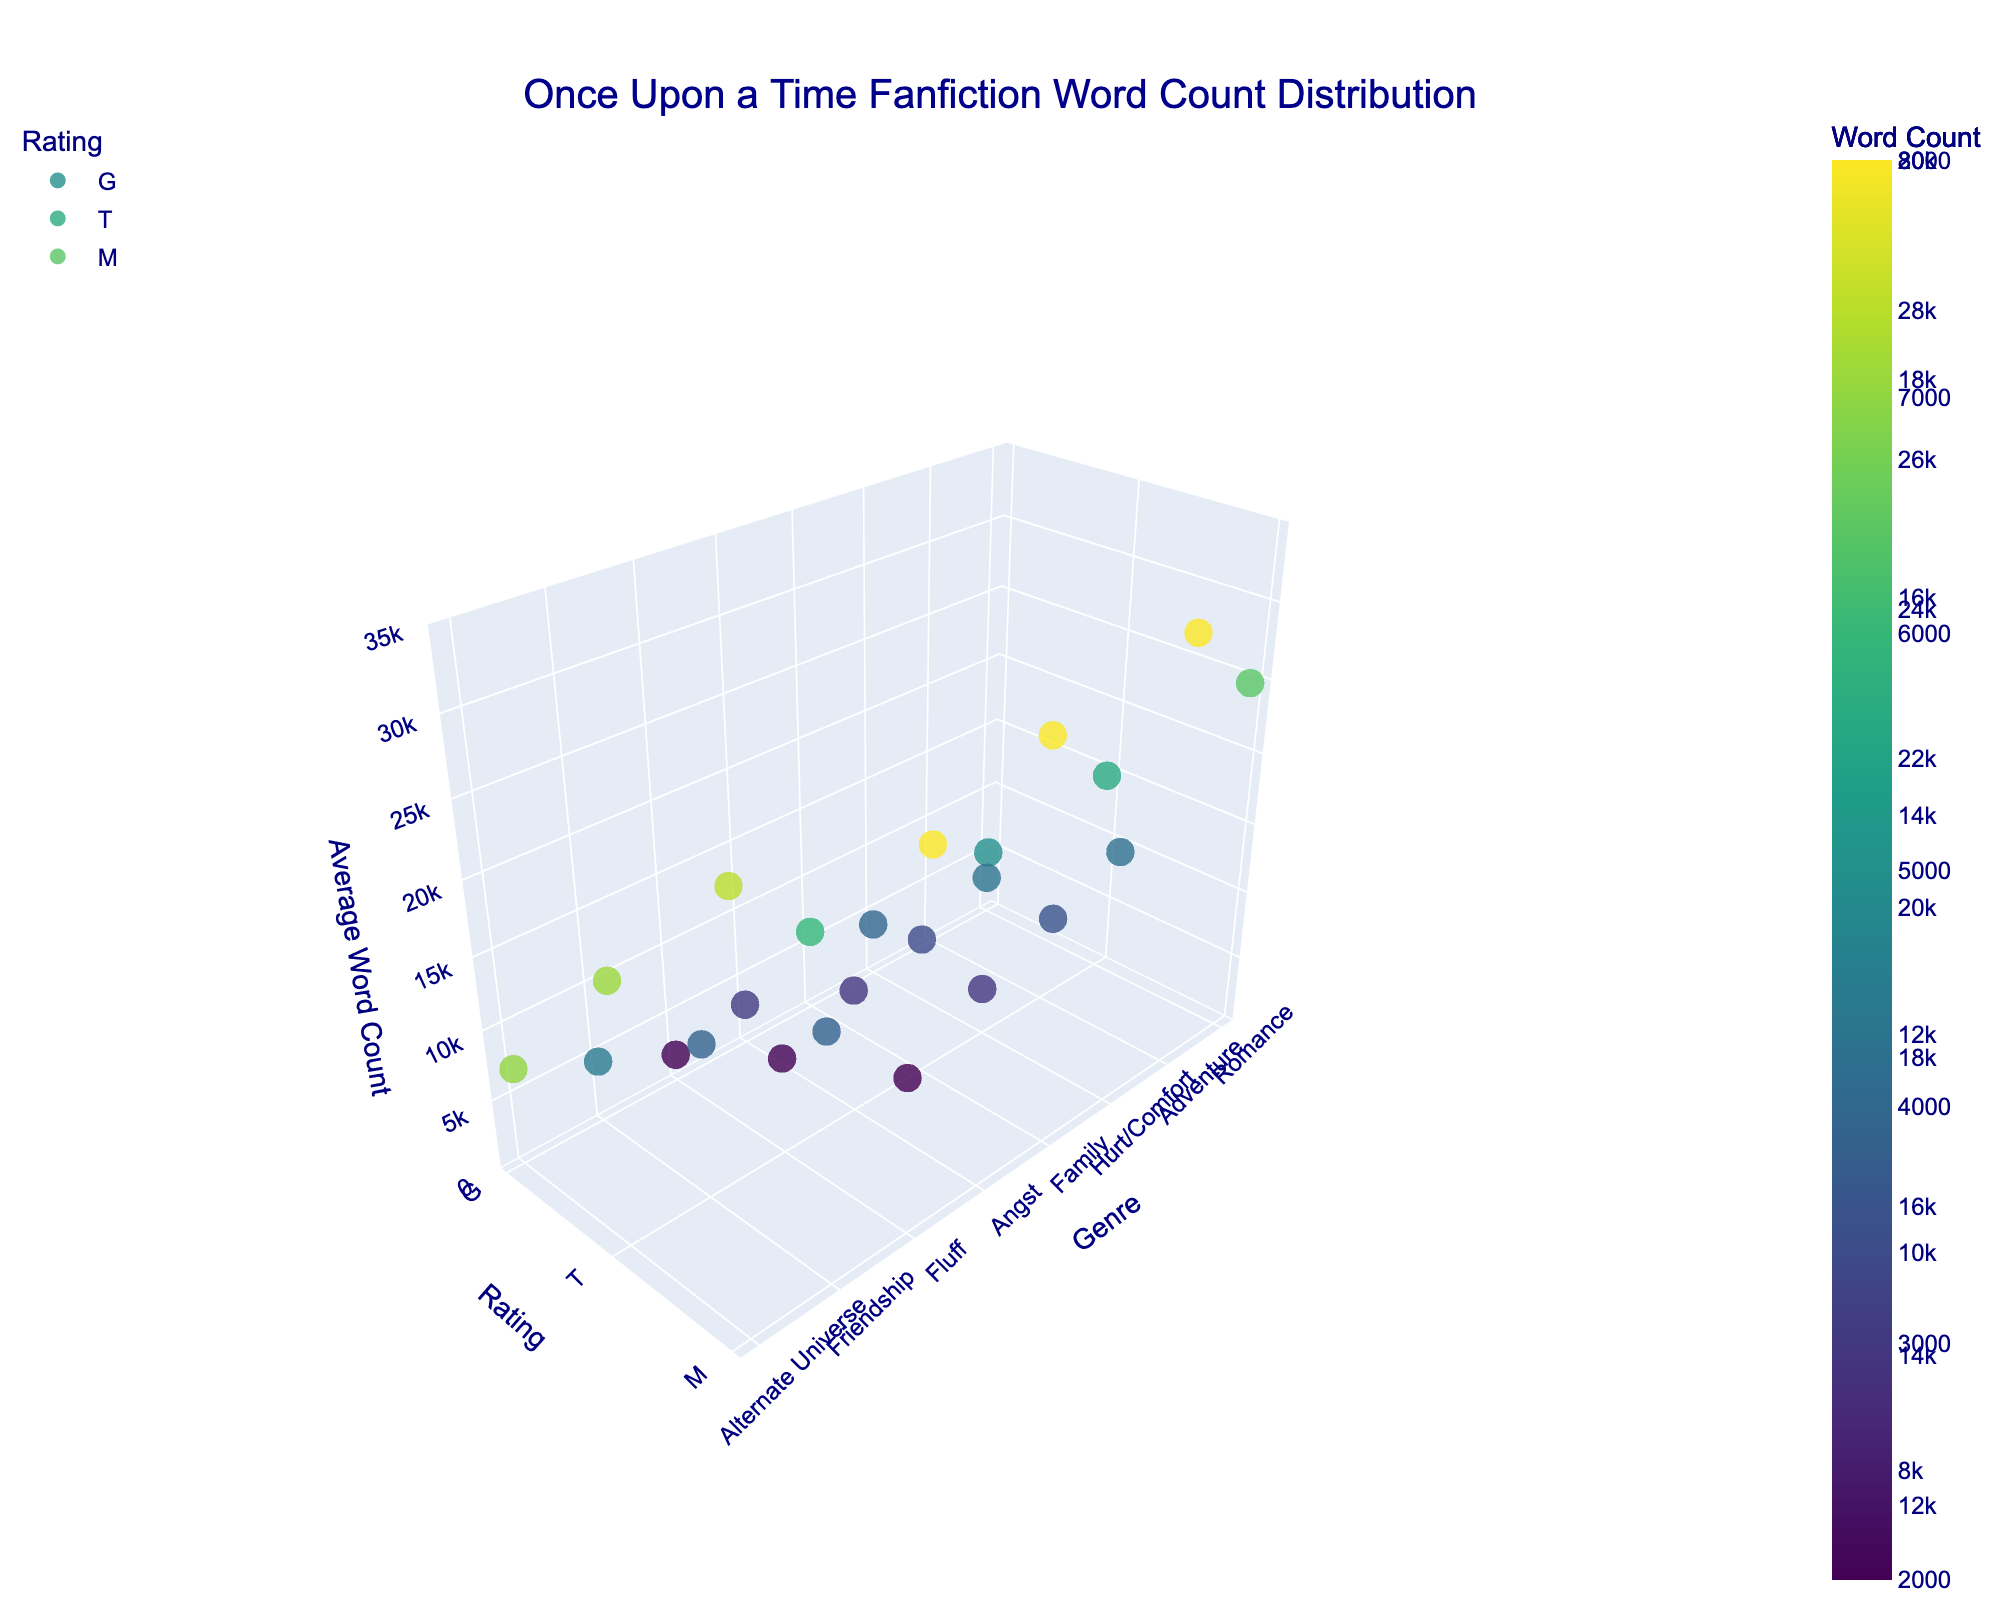What is the title of the figure? The title of the figure is typically positioned at the top and is written in larger font size compared to the other text elements in the figure.
Answer: Once Upon a Time Fanfiction Word Count Distribution What axis represents the different genres of fanfiction? In the 3D plot, the genres are distributed along the x-axis, as most categorical variables are plotted along this axis.
Answer: x-axis How many data points are there for the rating 'M'? For each genre in the plot, there are three data points corresponding to the ratings 'G,' 'T,' and 'M.' Since there are 8 genres, the number of data points for 'M' will be 8.
Answer: 8 Which genre has the highest average word count for the rating 'T'? In the 3D scatter plot, the highest point for the 'T' rating corresponds to the genre with the highest average word count.
Answer: Adventure What is the average word count for the genre 'Romance' across all ratings? The average word count can be calculated by summing the word counts for 'Romance' across all ratings and dividing by the number of ratings. (5000 + 15000 + 25000) / 3 = 45000 / 3
Answer: 15000 Which genre shows the least increase in average word count from rating 'T' to rating 'M'? Comparing the differences in average word counts between ratings 'T' and 'M' for each genre, the smallest difference can be found. For example, 'Hurt/Comfort': 18000 - 12000 = 6000, and so on for other genres.
Answer: Hurt/Comfort What color represents the highest average word counts in the 3D plot? In the figure, a viridis colorscale is used, where higher word counts are typically represented by colors toward the yellow part of the spectrum.
Answer: Yellow Which genre-rating combination has the lowest average word count? By looking at the lowest point in the 3D plot or checking the data for the minimum word count, 'Fluff' with rating 'G' has 2000 words.
Answer: Fluff, G Which rating has the most variation in word counts across different genres? The variation can be determined by the range of word counts for each rating. 'M' rating has word counts varying from 11000 to 30000 across different genres.
Answer: M 